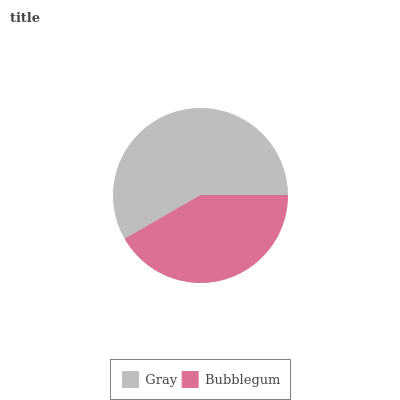Is Bubblegum the minimum?
Answer yes or no. Yes. Is Gray the maximum?
Answer yes or no. Yes. Is Bubblegum the maximum?
Answer yes or no. No. Is Gray greater than Bubblegum?
Answer yes or no. Yes. Is Bubblegum less than Gray?
Answer yes or no. Yes. Is Bubblegum greater than Gray?
Answer yes or no. No. Is Gray less than Bubblegum?
Answer yes or no. No. Is Gray the high median?
Answer yes or no. Yes. Is Bubblegum the low median?
Answer yes or no. Yes. Is Bubblegum the high median?
Answer yes or no. No. Is Gray the low median?
Answer yes or no. No. 